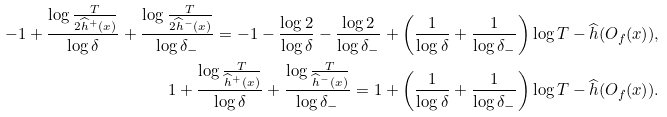<formula> <loc_0><loc_0><loc_500><loc_500>- 1 + \frac { \log { \frac { T } { 2 \widehat { h } ^ { + } ( x ) } } } { \log \delta } + \frac { \log { \frac { T } { 2 \widehat { h } ^ { - } ( x ) } } } { \log \delta _ { - } } = - 1 - \frac { \log 2 } { \log \delta } - \frac { \log 2 } { \log \delta _ { - } } + \left ( \frac { 1 } { \log \delta } + \frac { 1 } { \log \delta _ { - } } \right ) \log T - \widehat { h } ( O _ { f } ( x ) ) , \\ 1 + \frac { \log { \frac { T } { \widehat { h } ^ { + } ( x ) } } } { \log \delta } + \frac { \log { \frac { T } { \widehat { h } ^ { - } ( x ) } } } { \log \delta _ { - } } = 1 + \left ( \frac { 1 } { \log \delta } + \frac { 1 } { \log \delta _ { - } } \right ) \log T - \widehat { h } ( O _ { f } ( x ) ) .</formula> 